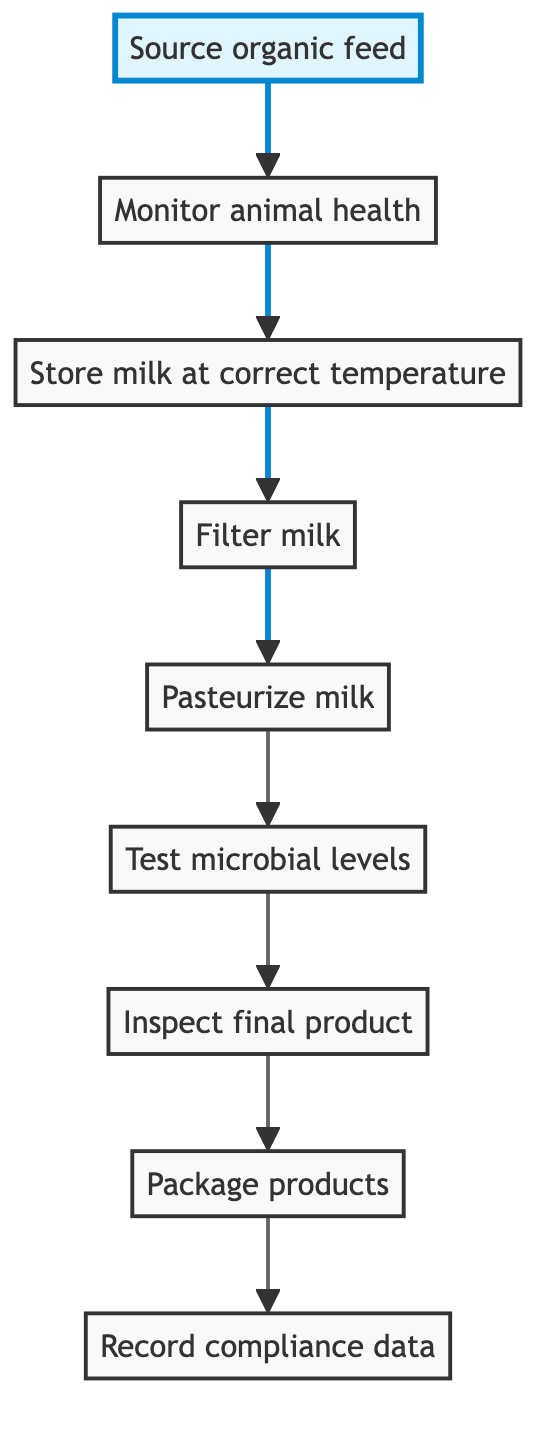What is the first step in the quality control procedures? The first step is to "Source organic feed." This is evident as it's the top node in the flowchart, indicating that it is the starting point for the process.
Answer: Source organic feed How many steps are there in the quality control procedures? Counting all nodes from "Source organic feed" to "Record compliance data," there are 9 steps in total. Each node represents a unique procedure in the quality control sequence.
Answer: 9 After filtering milk, what is the next step? The immediate next step after filtering milk is "Pasteurize milk." This can be determined by following the arrow from the node "Filter milk" to the next node in the flowchart.
Answer: Pasteurize milk What is the final step in the quality control procedures? The final step is "Record compliance data," which is indicated as the last node in the flowchart, showing that it concludes all procedures for quality control.
Answer: Record compliance data How is the filtered milk processed before it’s tested for microbial levels? The filtered milk is first pasteurized at the correct temperature to kill harmful bacteria before it is tested for microbial levels. This is shown in the flow from "Filter milk" to "Pasteurize milk" and then to "Test microbial levels."
Answer: Pasteurize milk Which step involves checking the health of dairy cows? The step that involves checking the health of dairy cows is "Monitor animal health." It is connected to "Source organic feed," indicating that monitoring health directly follows sourcing feed.
Answer: Monitor animal health What is the purpose of packaging the products? The products are packaged in eco-friendly materials to ensure sustainability and compliance with organic principles. This is indicated in the step titled "Package products" in the diagram.
Answer: Eco-friendly materials Is there any step following the inspection of the final product? No, there is no step following "Inspect final product." It is the last operation before recording compliance data, which solidifies its position in the quality control process.
Answer: No What is the relationship between "Monitor animal health" and "Source organic feed"? "Monitor animal health" directly follows "Source organic feed," indicating a sequential process where the health monitoring depends on having sourced appropriate organic feed first.
Answer: Sequential relationship 